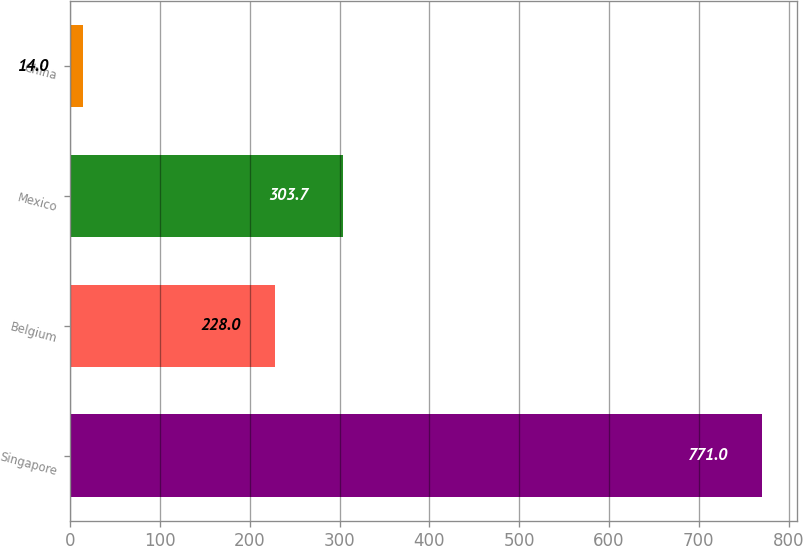Convert chart. <chart><loc_0><loc_0><loc_500><loc_500><bar_chart><fcel>Singapore<fcel>Belgium<fcel>Mexico<fcel>China<nl><fcel>771<fcel>228<fcel>303.7<fcel>14<nl></chart> 